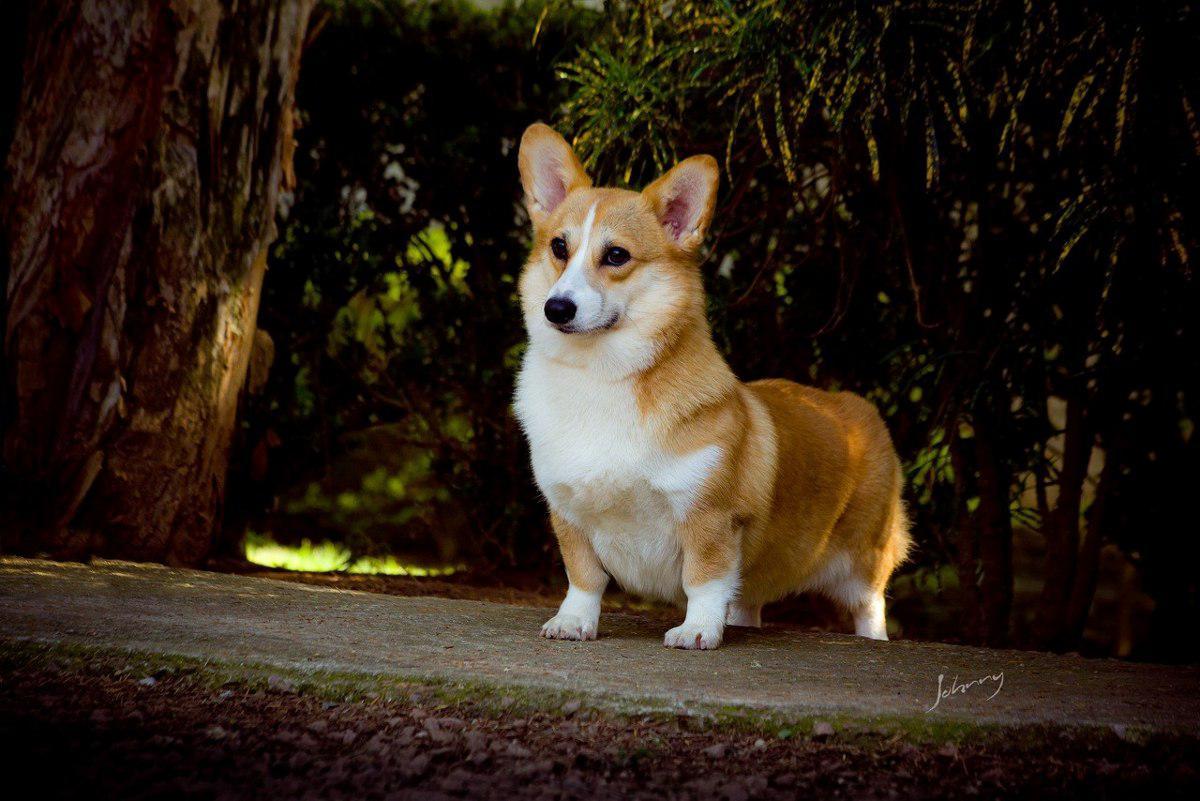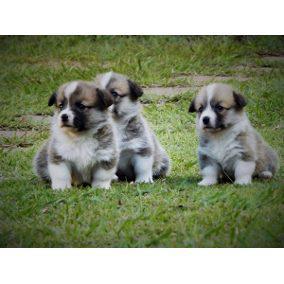The first image is the image on the left, the second image is the image on the right. For the images shown, is this caption "In at least one image there are three dog sitting next to each other in the grass." true? Answer yes or no. Yes. 